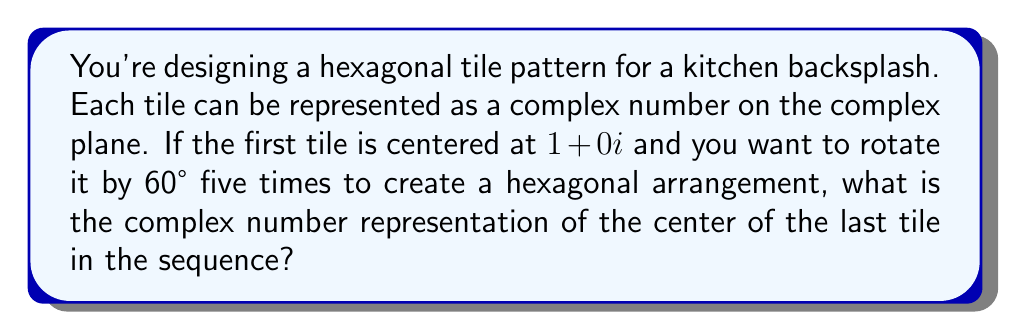Show me your answer to this math problem. Let's approach this step-by-step:

1) The rotation of 60° in the complex plane can be represented by multiplication with the complex number $e^{i\pi/3}$.

2) We start with the tile at $1+0i$. Let's call this $z_0$.

3) Each subsequent tile center is obtained by multiplying the previous one by $e^{i\pi/3}$:

   $z_1 = z_0 \cdot e^{i\pi/3}$
   $z_2 = z_1 \cdot e^{i\pi/3} = z_0 \cdot (e^{i\pi/3})^2$
   $z_3 = z_2 \cdot e^{i\pi/3} = z_0 \cdot (e^{i\pi/3})^3$
   $z_4 = z_3 \cdot e^{i\pi/3} = z_0 \cdot (e^{i\pi/3})^4$
   $z_5 = z_4 \cdot e^{i\pi/3} = z_0 \cdot (e^{i\pi/3})^5$

4) We're interested in $z_5$, which is $1 \cdot (e^{i\pi/3})^5$

5) $(e^{i\pi/3})^5 = e^{5i\pi/3} = \cos(5\pi/3) + i\sin(5\pi/3)$

6) $\cos(5\pi/3) = \cos(-\pi/3) = 1/2$
   $\sin(5\pi/3) = \sin(-\pi/3) = -\sqrt{3}/2$

7) Therefore, $z_5 = 1 \cdot (1/2 - i\sqrt{3}/2) = 1/2 - i\sqrt{3}/2$

[asy]
import geometry;

size(200);
draw(circle((0,0),1));
dot((1,0),red);
dot((0.5,sqrt(3)/2),red);
dot((-0.5,sqrt(3)/2),red);
dot((-1,0),red);
dot((-0.5,-sqrt(3)/2),red);
dot((0.5,-sqrt(3)/2),red);
label("$z_0$",(1,0),E);
label("$z_1$",(0.5,sqrt(3)/2),NE);
label("$z_2$",(-0.5,sqrt(3)/2),NW);
label("$z_3$",(-1,0),W);
label("$z_4$",(-0.5,-sqrt(3)/2),SW);
label("$z_5$",(0.5,-sqrt(3)/2),SE);
[/asy]
Answer: $\frac{1}{2} - i\frac{\sqrt{3}}{2}$ 